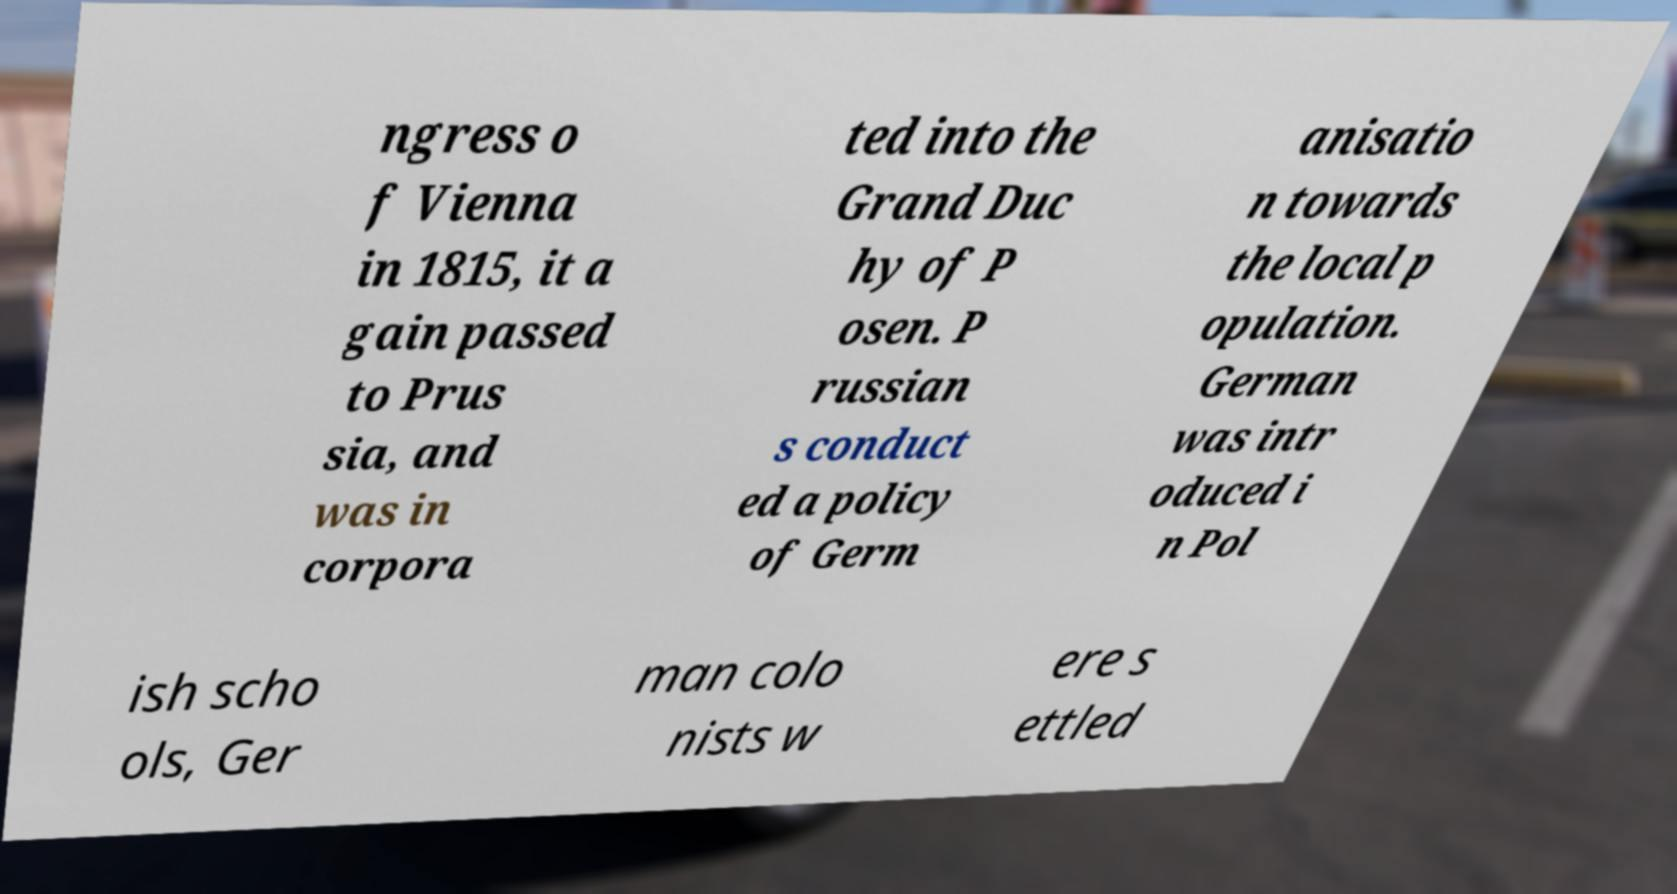Can you accurately transcribe the text from the provided image for me? ngress o f Vienna in 1815, it a gain passed to Prus sia, and was in corpora ted into the Grand Duc hy of P osen. P russian s conduct ed a policy of Germ anisatio n towards the local p opulation. German was intr oduced i n Pol ish scho ols, Ger man colo nists w ere s ettled 